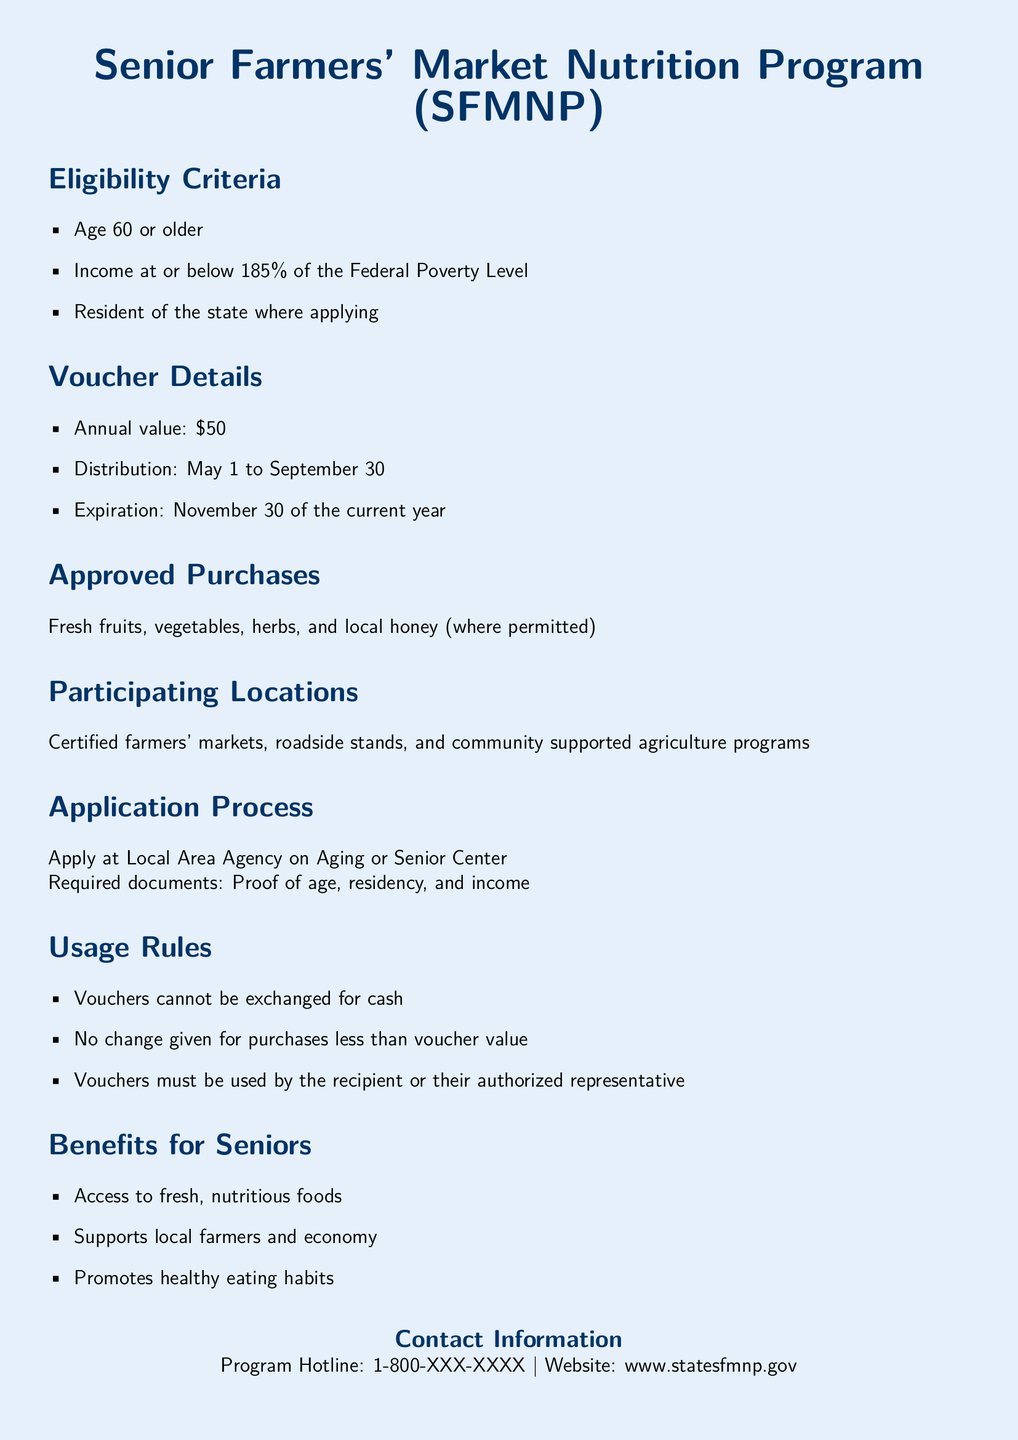What is the age requirement? The document states that the age requirement is 60 or older.
Answer: 60 What is the income limit for eligibility? The document mentions that the income must be at or below 185% of the Federal Poverty Level.
Answer: 185% What is the annual value of the vouchers? The annual value of the vouchers is specified in the document as $50.
Answer: $50 When do the vouchers expire? The expiration date for the vouchers is mentioned in the document as November 30 of the current year.
Answer: November 30 Where can eligible seniors apply for the vouchers? The document states that applications can be made at the Local Area Agency on Aging or Senior Center.
Answer: Local Area Agency on Aging or Senior Center What type of foods can vouchers be used for? The document states that vouchers can be used for fresh fruits, vegetables, herbs, and local honey.
Answer: Fresh fruits, vegetables, herbs, and local honey Can vouchers be exchanged for cash? The document clearly states that vouchers cannot be exchanged for cash.
Answer: No Who can use the vouchers? The document specifies that vouchers must be used by the recipient or their authorized representative.
Answer: Recipient or authorized representative What period are the vouchers distributed? The distribution of the vouchers is noted in the document to be from May 1 to September 30.
Answer: May 1 to September 30 